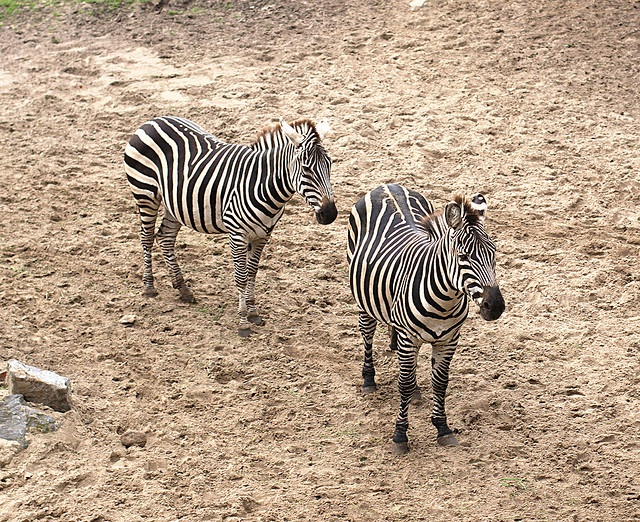Describe the objects in this image and their specific colors. I can see zebra in lightgreen, black, ivory, gray, and darkgray tones and zebra in lightgreen, black, ivory, gray, and darkgray tones in this image. 